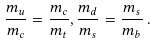<formula> <loc_0><loc_0><loc_500><loc_500>\frac { m _ { u } } { m _ { c } } = \frac { m _ { c } } { m _ { t } } , \frac { m _ { d } } { m _ { s } } = \frac { m _ { s } } { m _ { b } } \, .</formula> 